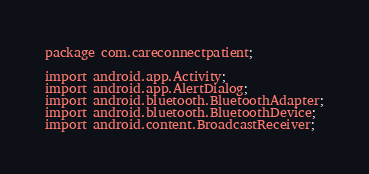Convert code to text. <code><loc_0><loc_0><loc_500><loc_500><_Java_>package com.careconnectpatient;

import android.app.Activity;
import android.app.AlertDialog;
import android.bluetooth.BluetoothAdapter;
import android.bluetooth.BluetoothDevice;
import android.content.BroadcastReceiver;</code> 